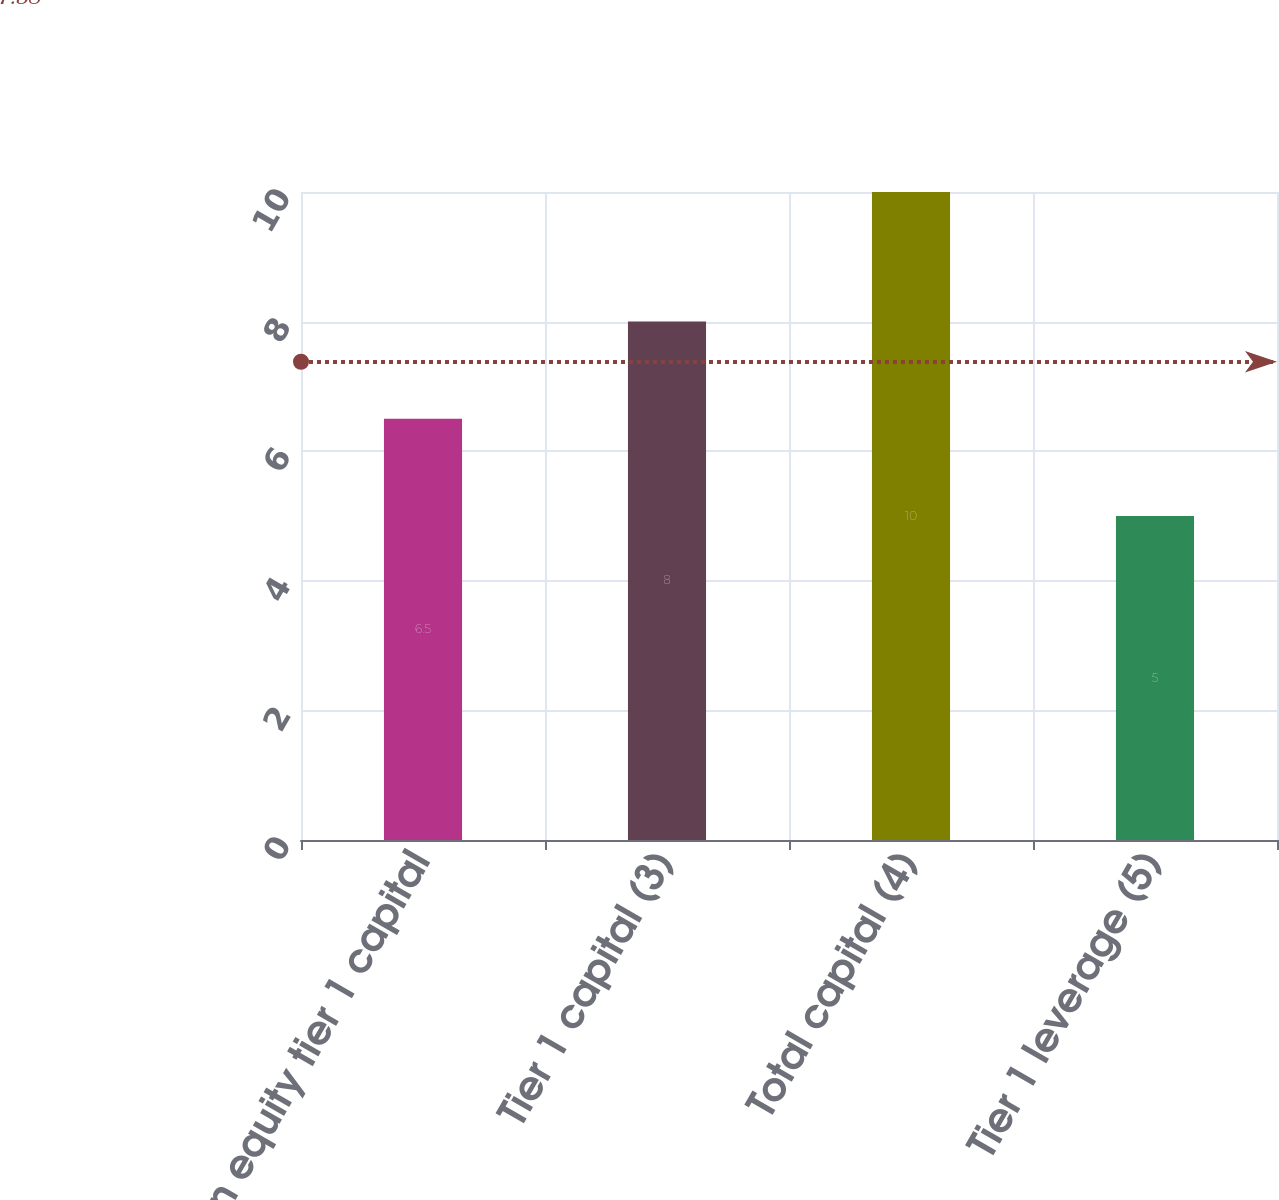Convert chart. <chart><loc_0><loc_0><loc_500><loc_500><bar_chart><fcel>Common equity tier 1 capital<fcel>Tier 1 capital (3)<fcel>Total capital (4)<fcel>Tier 1 leverage (5)<nl><fcel>6.5<fcel>8<fcel>10<fcel>5<nl></chart> 